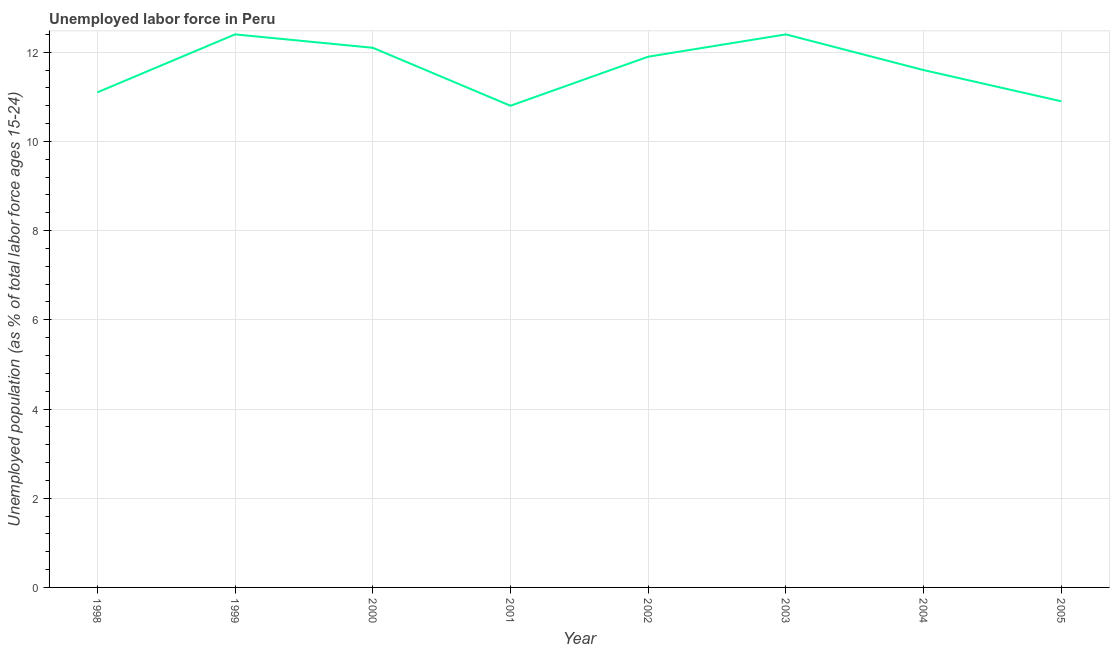What is the total unemployed youth population in 2003?
Keep it short and to the point. 12.4. Across all years, what is the maximum total unemployed youth population?
Provide a short and direct response. 12.4. Across all years, what is the minimum total unemployed youth population?
Ensure brevity in your answer.  10.8. In which year was the total unemployed youth population maximum?
Ensure brevity in your answer.  1999. In which year was the total unemployed youth population minimum?
Your answer should be compact. 2001. What is the sum of the total unemployed youth population?
Provide a succinct answer. 93.2. What is the difference between the total unemployed youth population in 2000 and 2003?
Your answer should be very brief. -0.3. What is the average total unemployed youth population per year?
Ensure brevity in your answer.  11.65. What is the median total unemployed youth population?
Give a very brief answer. 11.75. In how many years, is the total unemployed youth population greater than 1.6 %?
Your answer should be compact. 8. Do a majority of the years between 1999 and 2004 (inclusive) have total unemployed youth population greater than 12 %?
Your answer should be very brief. No. What is the ratio of the total unemployed youth population in 1998 to that in 2000?
Your answer should be compact. 0.92. Is the total unemployed youth population in 1998 less than that in 2002?
Your answer should be compact. Yes. Is the difference between the total unemployed youth population in 2002 and 2005 greater than the difference between any two years?
Provide a short and direct response. No. What is the difference between the highest and the second highest total unemployed youth population?
Offer a terse response. 0. Is the sum of the total unemployed youth population in 2000 and 2004 greater than the maximum total unemployed youth population across all years?
Keep it short and to the point. Yes. What is the difference between the highest and the lowest total unemployed youth population?
Provide a short and direct response. 1.6. In how many years, is the total unemployed youth population greater than the average total unemployed youth population taken over all years?
Ensure brevity in your answer.  4. Does the total unemployed youth population monotonically increase over the years?
Provide a succinct answer. No. How many lines are there?
Provide a succinct answer. 1. Are the values on the major ticks of Y-axis written in scientific E-notation?
Provide a succinct answer. No. Does the graph contain any zero values?
Give a very brief answer. No. What is the title of the graph?
Make the answer very short. Unemployed labor force in Peru. What is the label or title of the Y-axis?
Give a very brief answer. Unemployed population (as % of total labor force ages 15-24). What is the Unemployed population (as % of total labor force ages 15-24) of 1998?
Ensure brevity in your answer.  11.1. What is the Unemployed population (as % of total labor force ages 15-24) of 1999?
Keep it short and to the point. 12.4. What is the Unemployed population (as % of total labor force ages 15-24) in 2000?
Keep it short and to the point. 12.1. What is the Unemployed population (as % of total labor force ages 15-24) in 2001?
Keep it short and to the point. 10.8. What is the Unemployed population (as % of total labor force ages 15-24) in 2002?
Offer a very short reply. 11.9. What is the Unemployed population (as % of total labor force ages 15-24) of 2003?
Make the answer very short. 12.4. What is the Unemployed population (as % of total labor force ages 15-24) in 2004?
Offer a very short reply. 11.6. What is the Unemployed population (as % of total labor force ages 15-24) of 2005?
Offer a very short reply. 10.9. What is the difference between the Unemployed population (as % of total labor force ages 15-24) in 1998 and 2001?
Keep it short and to the point. 0.3. What is the difference between the Unemployed population (as % of total labor force ages 15-24) in 1998 and 2002?
Offer a very short reply. -0.8. What is the difference between the Unemployed population (as % of total labor force ages 15-24) in 1998 and 2003?
Provide a short and direct response. -1.3. What is the difference between the Unemployed population (as % of total labor force ages 15-24) in 1998 and 2005?
Your answer should be compact. 0.2. What is the difference between the Unemployed population (as % of total labor force ages 15-24) in 1999 and 2000?
Ensure brevity in your answer.  0.3. What is the difference between the Unemployed population (as % of total labor force ages 15-24) in 1999 and 2001?
Your response must be concise. 1.6. What is the difference between the Unemployed population (as % of total labor force ages 15-24) in 1999 and 2002?
Give a very brief answer. 0.5. What is the difference between the Unemployed population (as % of total labor force ages 15-24) in 1999 and 2003?
Keep it short and to the point. 0. What is the difference between the Unemployed population (as % of total labor force ages 15-24) in 1999 and 2005?
Provide a short and direct response. 1.5. What is the difference between the Unemployed population (as % of total labor force ages 15-24) in 2000 and 2004?
Ensure brevity in your answer.  0.5. What is the difference between the Unemployed population (as % of total labor force ages 15-24) in 2001 and 2002?
Give a very brief answer. -1.1. What is the difference between the Unemployed population (as % of total labor force ages 15-24) in 2001 and 2004?
Your answer should be very brief. -0.8. What is the difference between the Unemployed population (as % of total labor force ages 15-24) in 2001 and 2005?
Your answer should be very brief. -0.1. What is the ratio of the Unemployed population (as % of total labor force ages 15-24) in 1998 to that in 1999?
Your response must be concise. 0.9. What is the ratio of the Unemployed population (as % of total labor force ages 15-24) in 1998 to that in 2000?
Give a very brief answer. 0.92. What is the ratio of the Unemployed population (as % of total labor force ages 15-24) in 1998 to that in 2001?
Make the answer very short. 1.03. What is the ratio of the Unemployed population (as % of total labor force ages 15-24) in 1998 to that in 2002?
Provide a short and direct response. 0.93. What is the ratio of the Unemployed population (as % of total labor force ages 15-24) in 1998 to that in 2003?
Keep it short and to the point. 0.9. What is the ratio of the Unemployed population (as % of total labor force ages 15-24) in 1998 to that in 2004?
Your response must be concise. 0.96. What is the ratio of the Unemployed population (as % of total labor force ages 15-24) in 1998 to that in 2005?
Ensure brevity in your answer.  1.02. What is the ratio of the Unemployed population (as % of total labor force ages 15-24) in 1999 to that in 2000?
Your response must be concise. 1.02. What is the ratio of the Unemployed population (as % of total labor force ages 15-24) in 1999 to that in 2001?
Ensure brevity in your answer.  1.15. What is the ratio of the Unemployed population (as % of total labor force ages 15-24) in 1999 to that in 2002?
Your answer should be very brief. 1.04. What is the ratio of the Unemployed population (as % of total labor force ages 15-24) in 1999 to that in 2003?
Give a very brief answer. 1. What is the ratio of the Unemployed population (as % of total labor force ages 15-24) in 1999 to that in 2004?
Your answer should be compact. 1.07. What is the ratio of the Unemployed population (as % of total labor force ages 15-24) in 1999 to that in 2005?
Provide a succinct answer. 1.14. What is the ratio of the Unemployed population (as % of total labor force ages 15-24) in 2000 to that in 2001?
Make the answer very short. 1.12. What is the ratio of the Unemployed population (as % of total labor force ages 15-24) in 2000 to that in 2003?
Provide a succinct answer. 0.98. What is the ratio of the Unemployed population (as % of total labor force ages 15-24) in 2000 to that in 2004?
Your answer should be compact. 1.04. What is the ratio of the Unemployed population (as % of total labor force ages 15-24) in 2000 to that in 2005?
Your response must be concise. 1.11. What is the ratio of the Unemployed population (as % of total labor force ages 15-24) in 2001 to that in 2002?
Ensure brevity in your answer.  0.91. What is the ratio of the Unemployed population (as % of total labor force ages 15-24) in 2001 to that in 2003?
Provide a short and direct response. 0.87. What is the ratio of the Unemployed population (as % of total labor force ages 15-24) in 2001 to that in 2004?
Make the answer very short. 0.93. What is the ratio of the Unemployed population (as % of total labor force ages 15-24) in 2002 to that in 2003?
Ensure brevity in your answer.  0.96. What is the ratio of the Unemployed population (as % of total labor force ages 15-24) in 2002 to that in 2004?
Offer a very short reply. 1.03. What is the ratio of the Unemployed population (as % of total labor force ages 15-24) in 2002 to that in 2005?
Provide a short and direct response. 1.09. What is the ratio of the Unemployed population (as % of total labor force ages 15-24) in 2003 to that in 2004?
Your answer should be compact. 1.07. What is the ratio of the Unemployed population (as % of total labor force ages 15-24) in 2003 to that in 2005?
Offer a very short reply. 1.14. What is the ratio of the Unemployed population (as % of total labor force ages 15-24) in 2004 to that in 2005?
Make the answer very short. 1.06. 